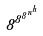Convert formula to latex. <formula><loc_0><loc_0><loc_500><loc_500>8 ^ { 8 ^ { 8 ^ { n ^ { h } } } }</formula> 